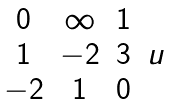<formula> <loc_0><loc_0><loc_500><loc_500>\begin{matrix} 0 & \infty & 1 & \\ 1 & - 2 & 3 & u \\ - 2 & 1 & 0 & \\ \end{matrix}</formula> 